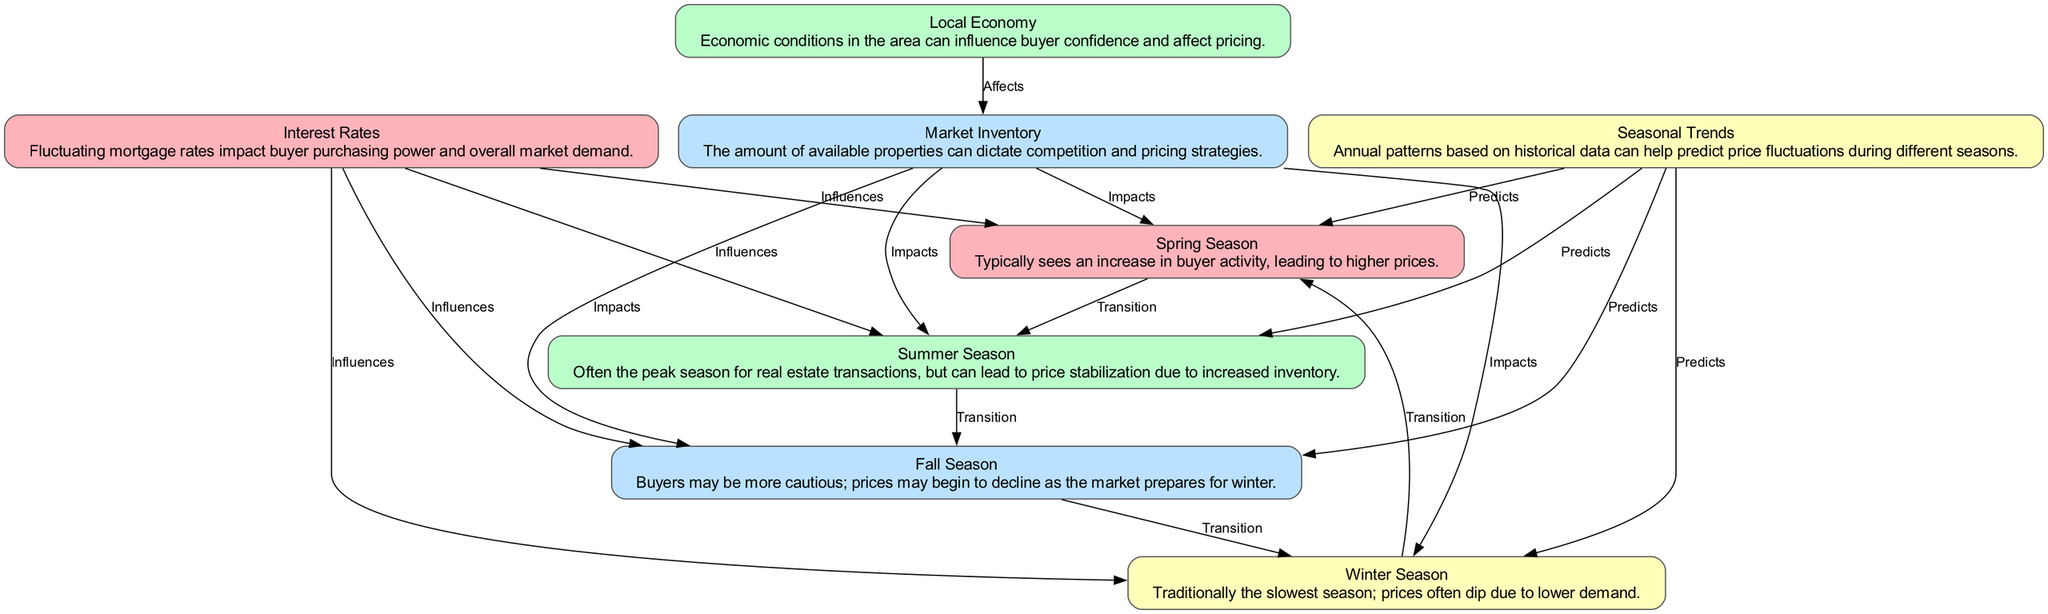What season typically sees higher prices due to increased buyer activity? According to the diagram, the "Spring Season" is indicated to see an increase in buyer activity, which leads to higher prices.
Answer: Spring Season How many seasons are represented in this diagram? The diagram contains four seasons: Spring, Summer, Fall, and Winter.
Answer: Four What season is known for having lower demand and traditionally sees a price dip? The "Winter Season" is recognized as the slowest season with lower demand, resulting in price dips.
Answer: Winter Season Which economic factor influences all four seasons? The "Interest Rates" node shows that fluctuating mortgage rates impact the price and demand across all four seasons.
Answer: Interest Rates What is the relationship between Market Inventory and the seasons? The edges show that "Market Inventory" impacts all four seasons, suggesting that the available properties affect pricing strategies during these times.
Answer: Impacts Which season transitions to Summer? The diagram indicates that the "Spring Season" transitions to "Summer Season," demonstrating a continuous flow between the two.
Answer: Summer Season Which two nodes have the relationship "Affects"? The relationship "Affects" is between the "Local Economy" and "Market Inventory," indicating that economic conditions impact inventory levels.
Answer: Local Economy and Market Inventory What do Seasonal Trends predict? The "Seasonal Trends" node predicts price behaviors during all four seasons based on historical data patterns, which means it influences Spring, Summer, Fall, and Winter.
Answer: Predicts Which season follows after Fall according to the transitions? The diagram illustrates that the "Fall Season" transitions to the "Winter Season," indicating the seasonal flow.
Answer: Winter Season How does Market Inventory influence Spring Season? The diagram shows a direct impact from "Market Inventory" to "Spring Season," meaning the inventory levels affect pricing in Spring specifically.
Answer: Impacts 